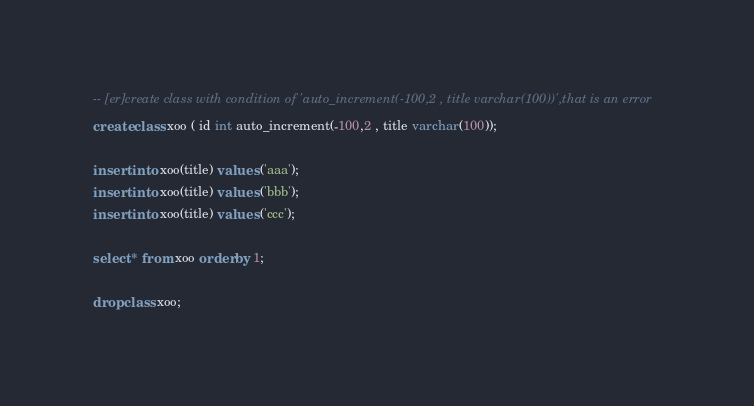Convert code to text. <code><loc_0><loc_0><loc_500><loc_500><_SQL_>-- [er]create class with condition of 'auto_increment(-100,2 , title varchar(100))',that is an error
create class xoo ( id int auto_increment(-100,2 , title varchar(100));

insert into xoo(title) values ('aaa');
insert into xoo(title) values ('bbb');
insert into xoo(title) values ('ccc');

select * from xoo order by 1;

drop class xoo;</code> 